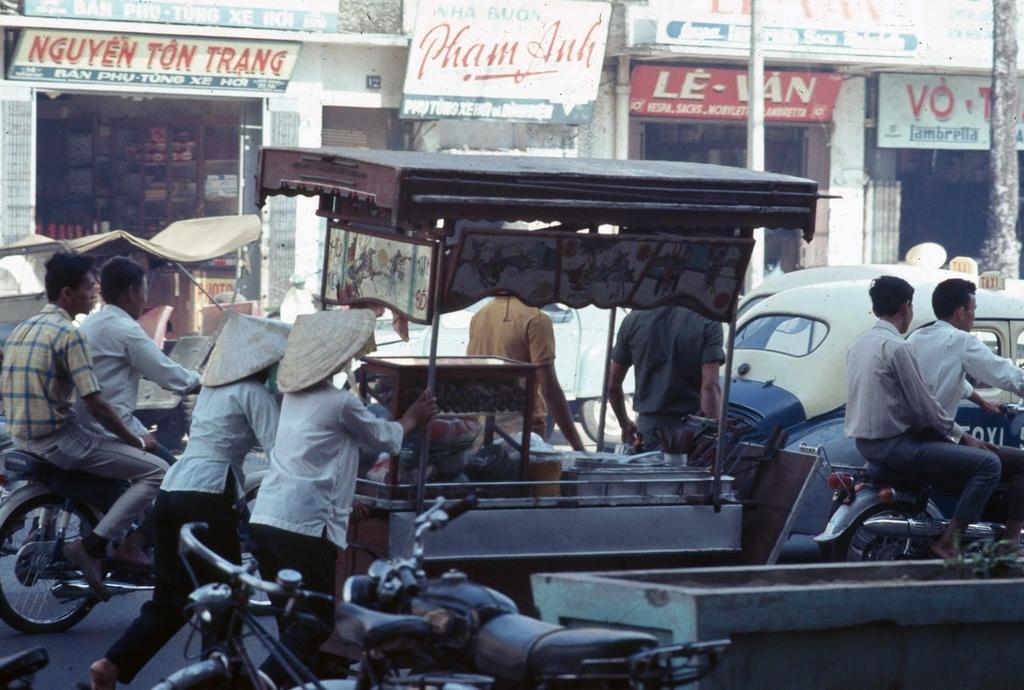In one or two sentences, can you explain what this image depicts? Here we can see vehicles on the road and there are few persons riding on the bikes and two persons are pushing a cart in which we can see some items and at the bottom we can see a bicycle and a bike and a plant in a pot. In the background we can see stores,hoardings on the wall,pole and some other objects. 